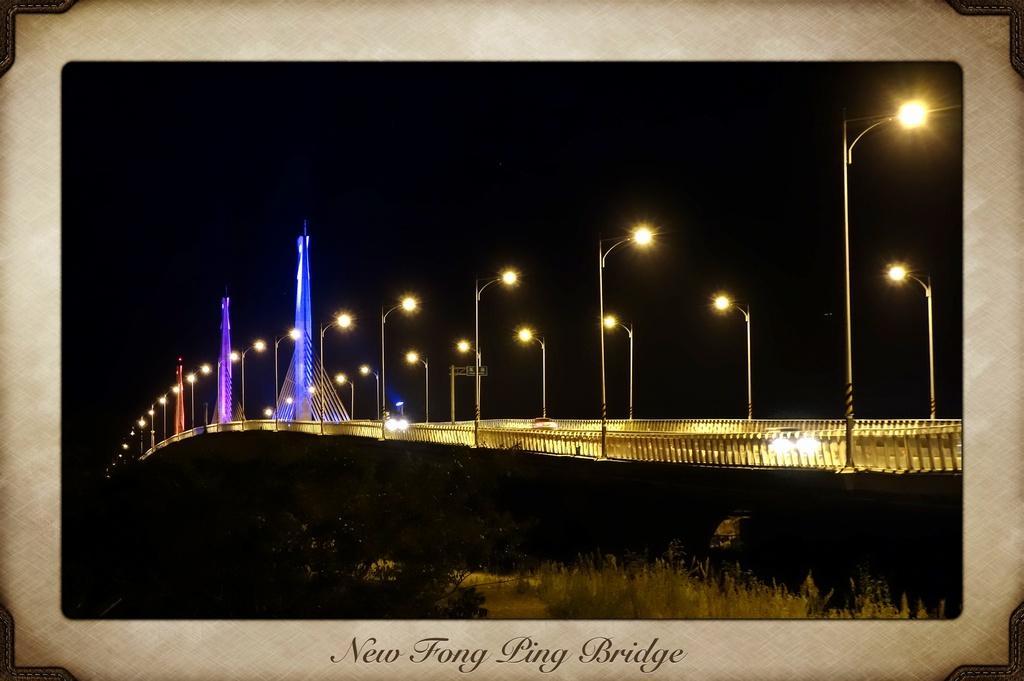In one or two sentences, can you explain what this image depicts? In the image in the center there is a frame. On the frame, we can see plants, fences, poles, lights, banners etc.. And we can see something written on the frame. 